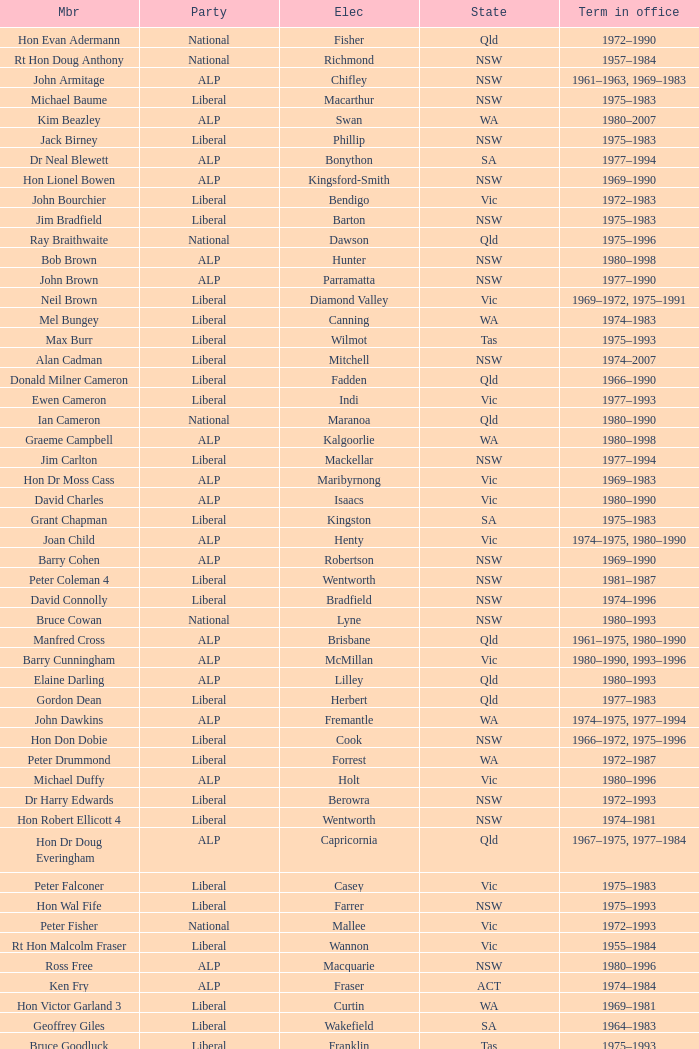What party is Mick Young a member of? ALP. 